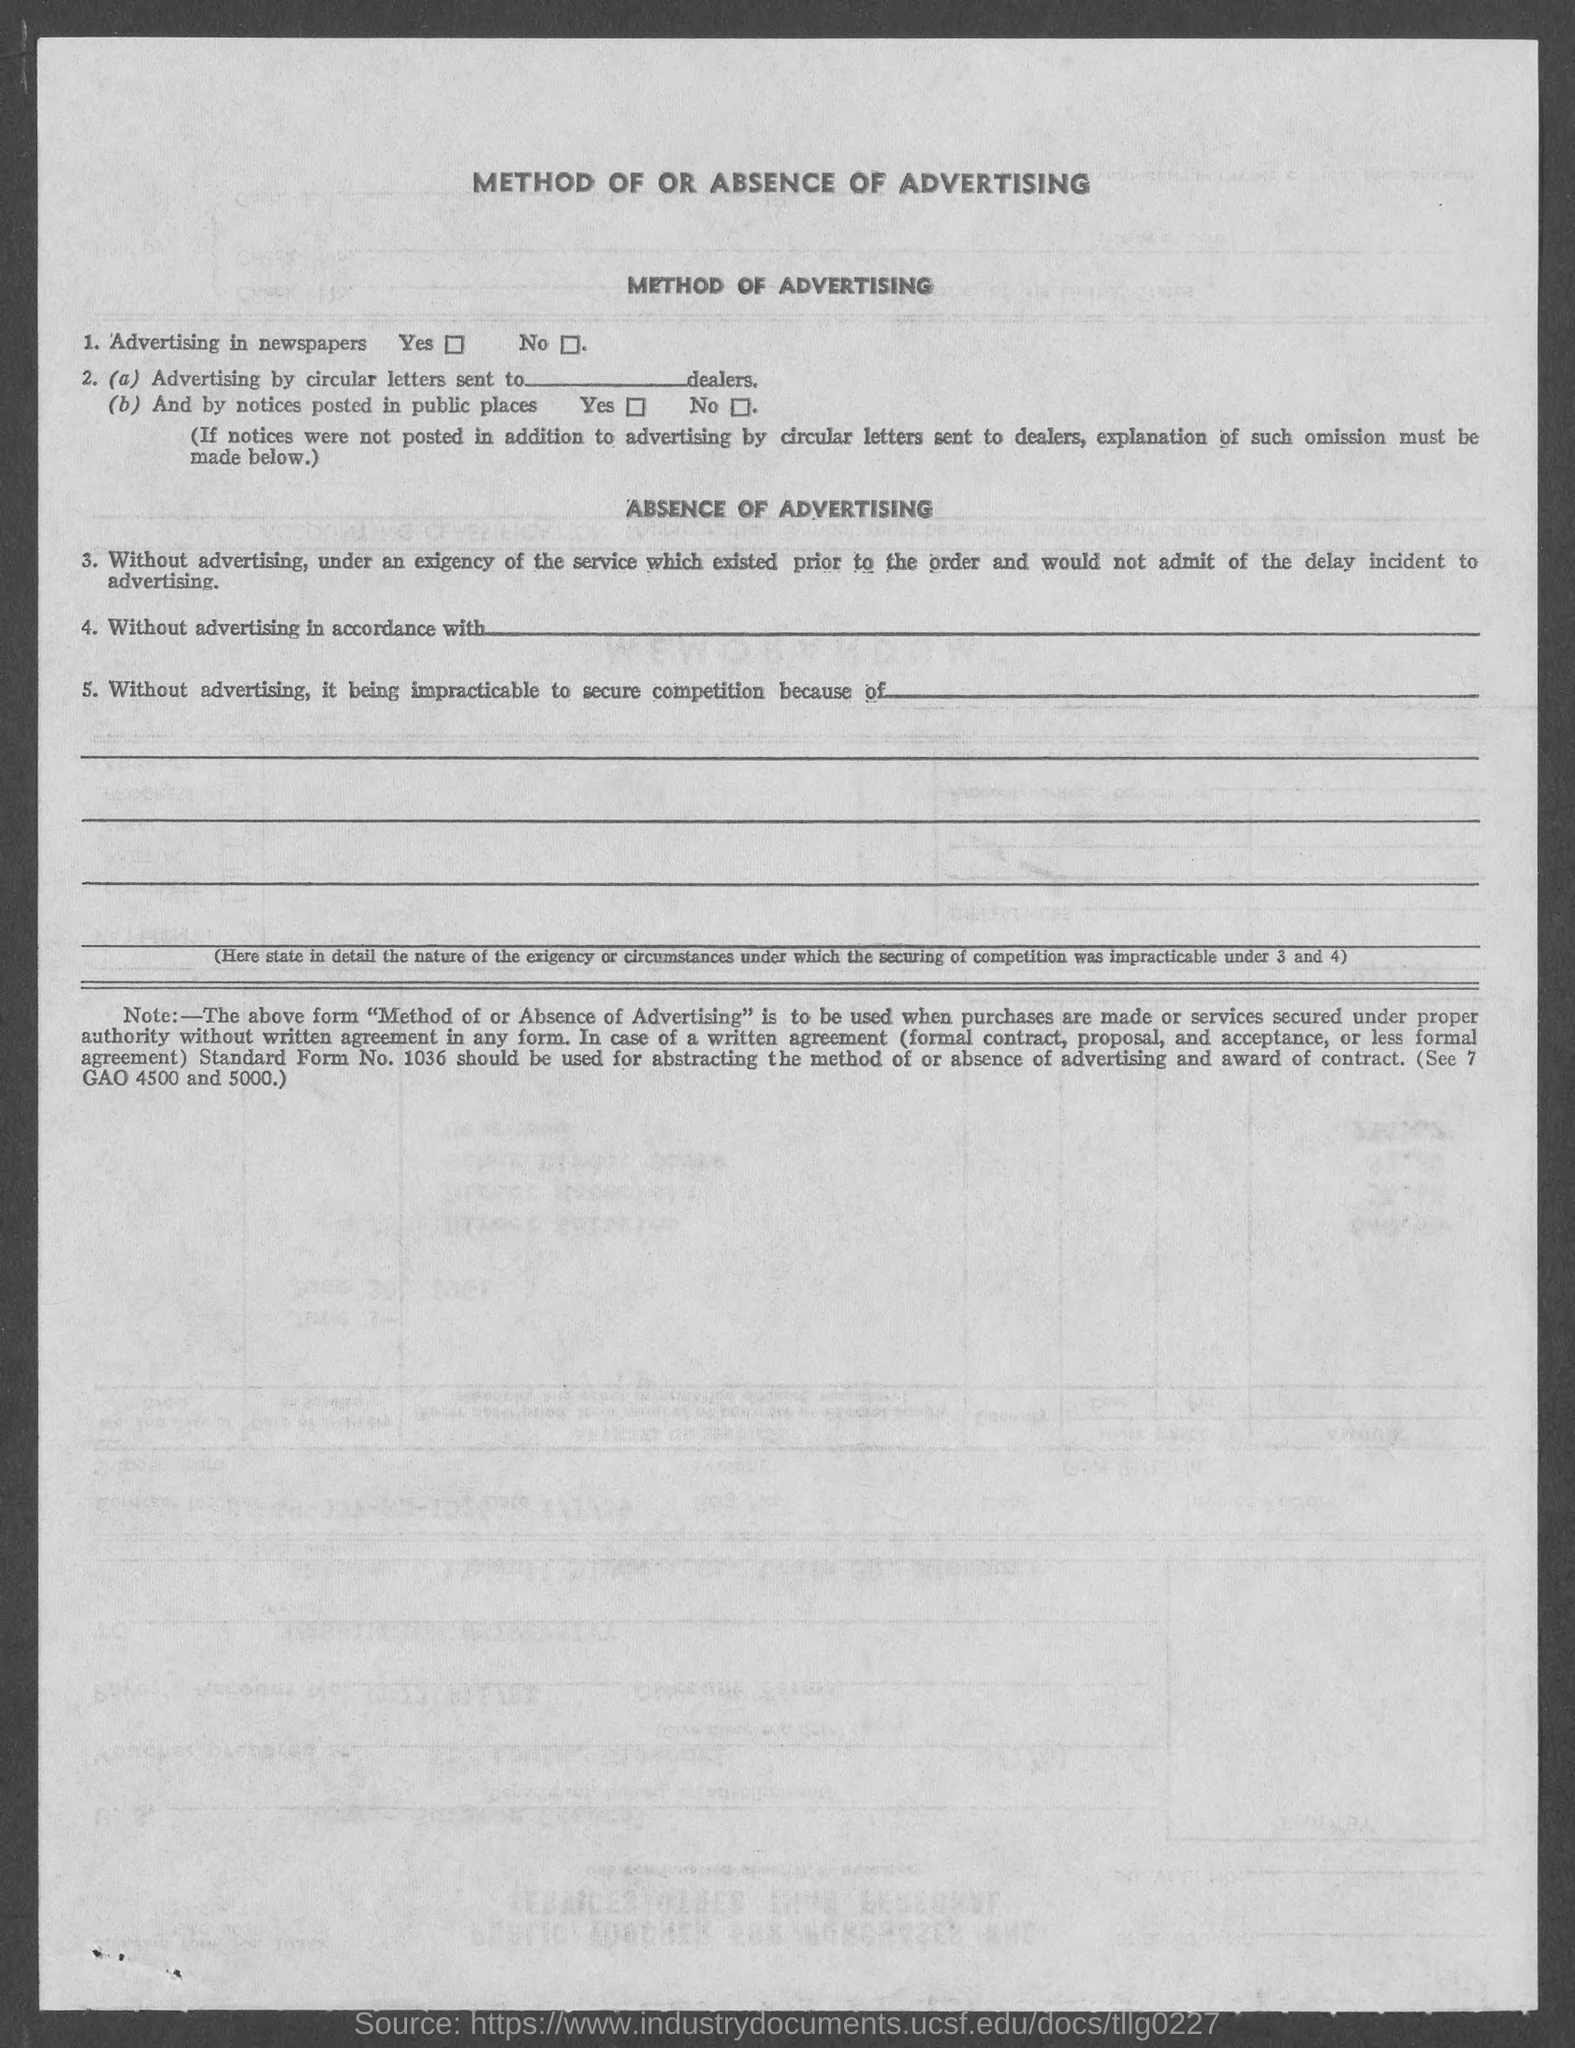List a handful of essential elements in this visual. The heading at the top of the page is 'Method of or Absence of Advertising,' which declares the topic of the text. 